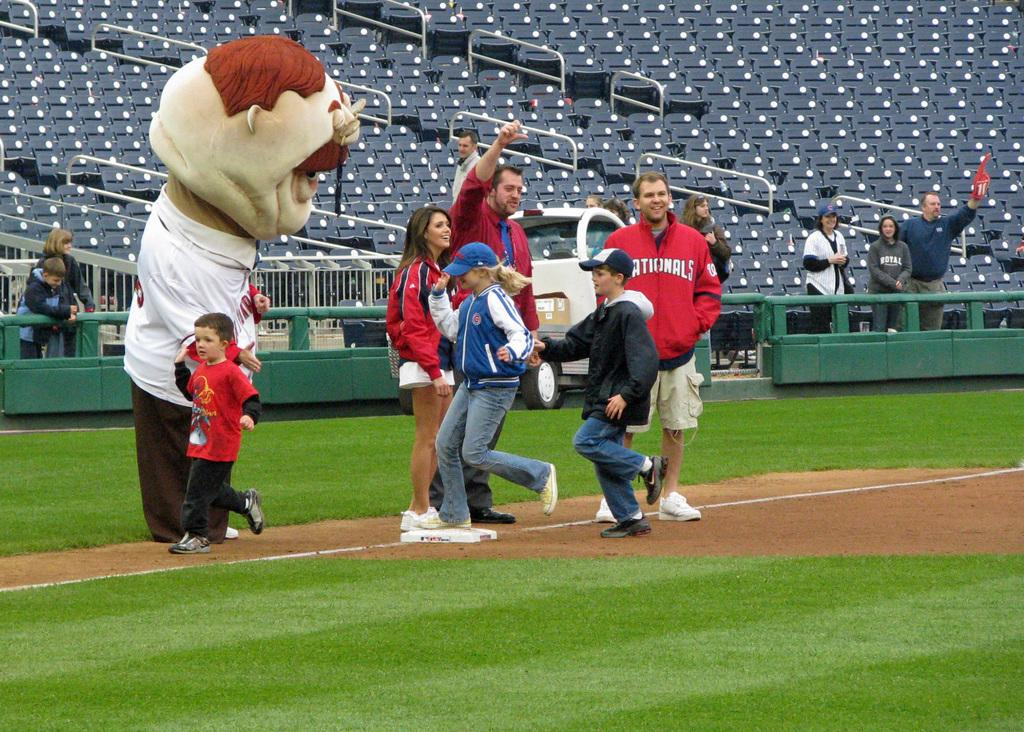<image>
Create a compact narrative representing the image presented. A Teddy Roosevelt mascot high fives kids as they round third base at the Nationals' baseball park. 